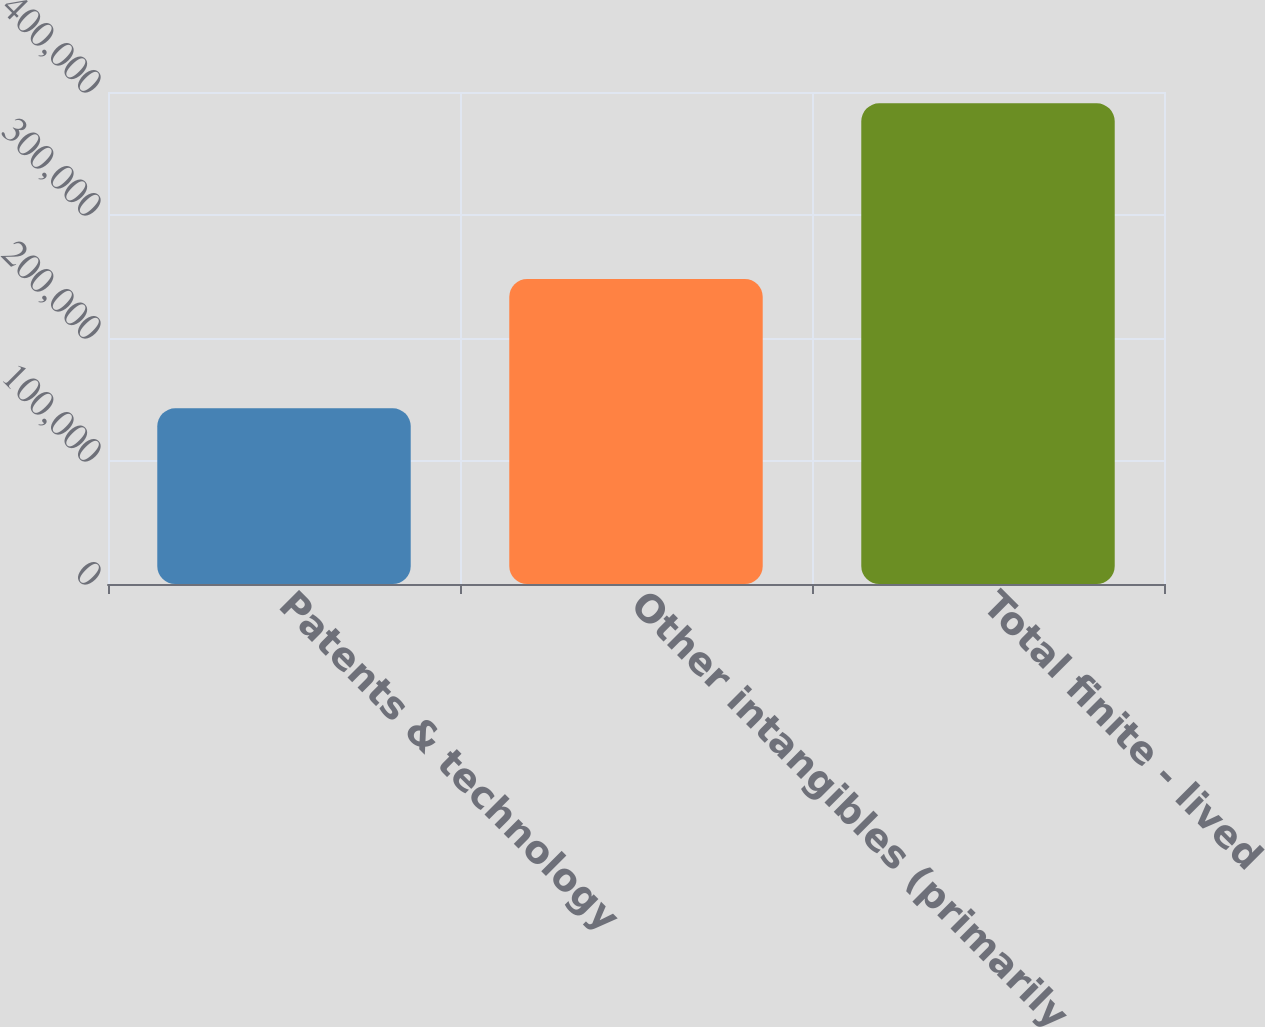Convert chart to OTSL. <chart><loc_0><loc_0><loc_500><loc_500><bar_chart><fcel>Patents & technology<fcel>Other intangibles (primarily<fcel>Total finite - lived<nl><fcel>142850<fcel>247984<fcel>390834<nl></chart> 